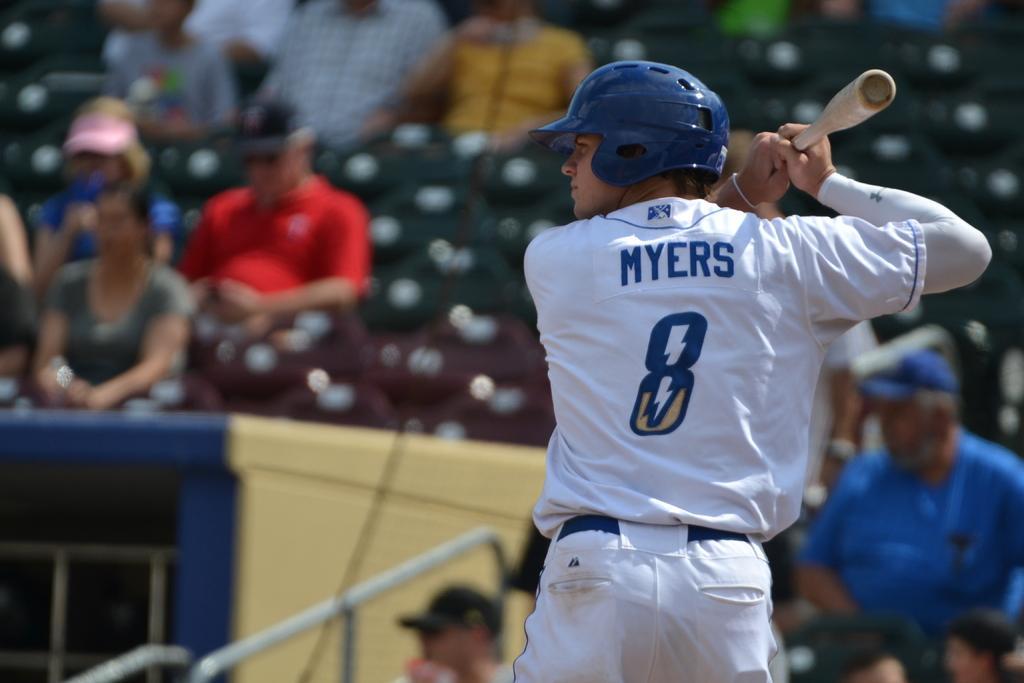Could you give a brief overview of what you see in this image? In this image we can see a man wearing a helmet standing holding a baseball bat. On the backside we can see some metal poles and a group of people sitting on the chairs. We can also see some empty chairs. 